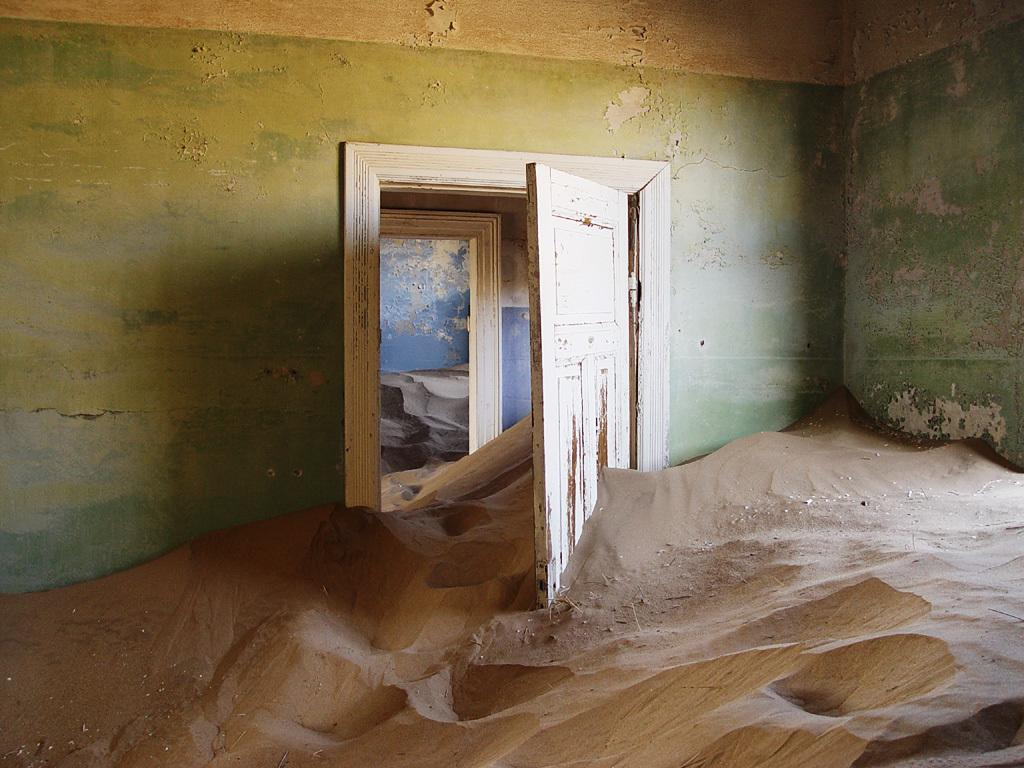What type of flooring is present in the room? There is sand in the room. What color is the wall in the room? The wall in the room has a green color. What color is the door in the room? The door in the room is white. How many other rooms with sand can be seen in the background? There are two other rooms with sand in the background. How many fish can be seen swimming in the sand in the image? There are no fish present in the image; it features a room with sand on the floor. What type of comb is used to clean the sand in the image? There is no comb present in the image, and the sand is not being cleaned. 